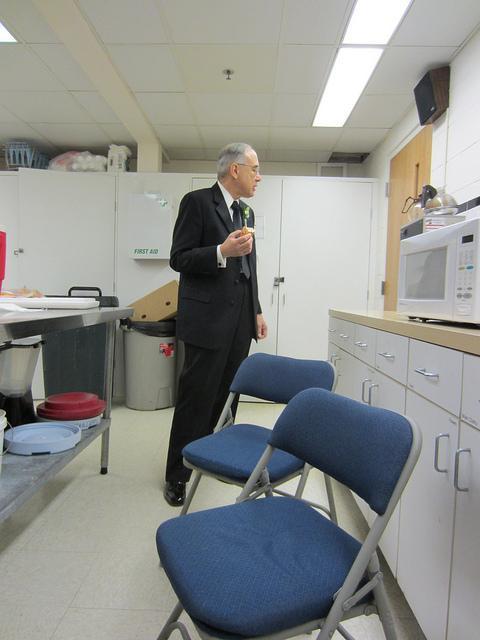How many blue chairs are there?
Give a very brief answer. 2. How many chairs are there?
Give a very brief answer. 2. 